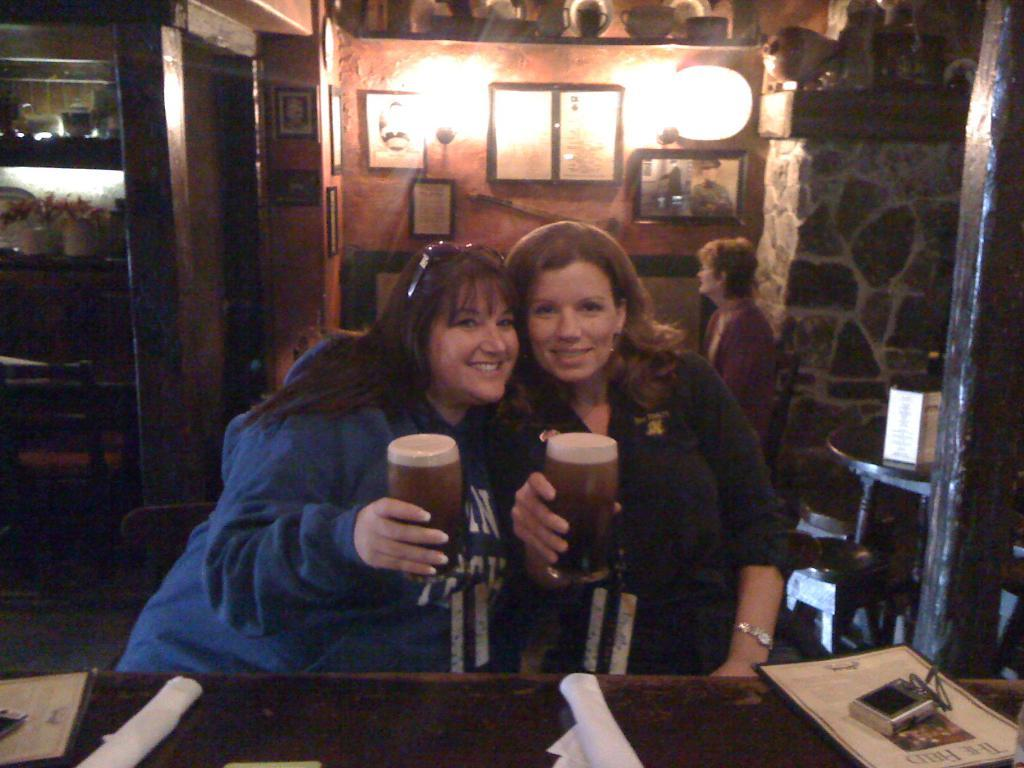How many women are visible in the image? There are three women visible in the image. What are the two women in the front doing? The two women in the front are having beer. Can you describe the position of the third woman in the image? The third woman is sitting behind the other two women in the image. What type of zephyr can be seen playing with a slip in the image? There is no zephyr or slip present in the image. 